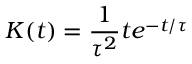Convert formula to latex. <formula><loc_0><loc_0><loc_500><loc_500>K ( t ) = \frac { 1 } { \tau ^ { 2 } } t e ^ { - t / \tau }</formula> 